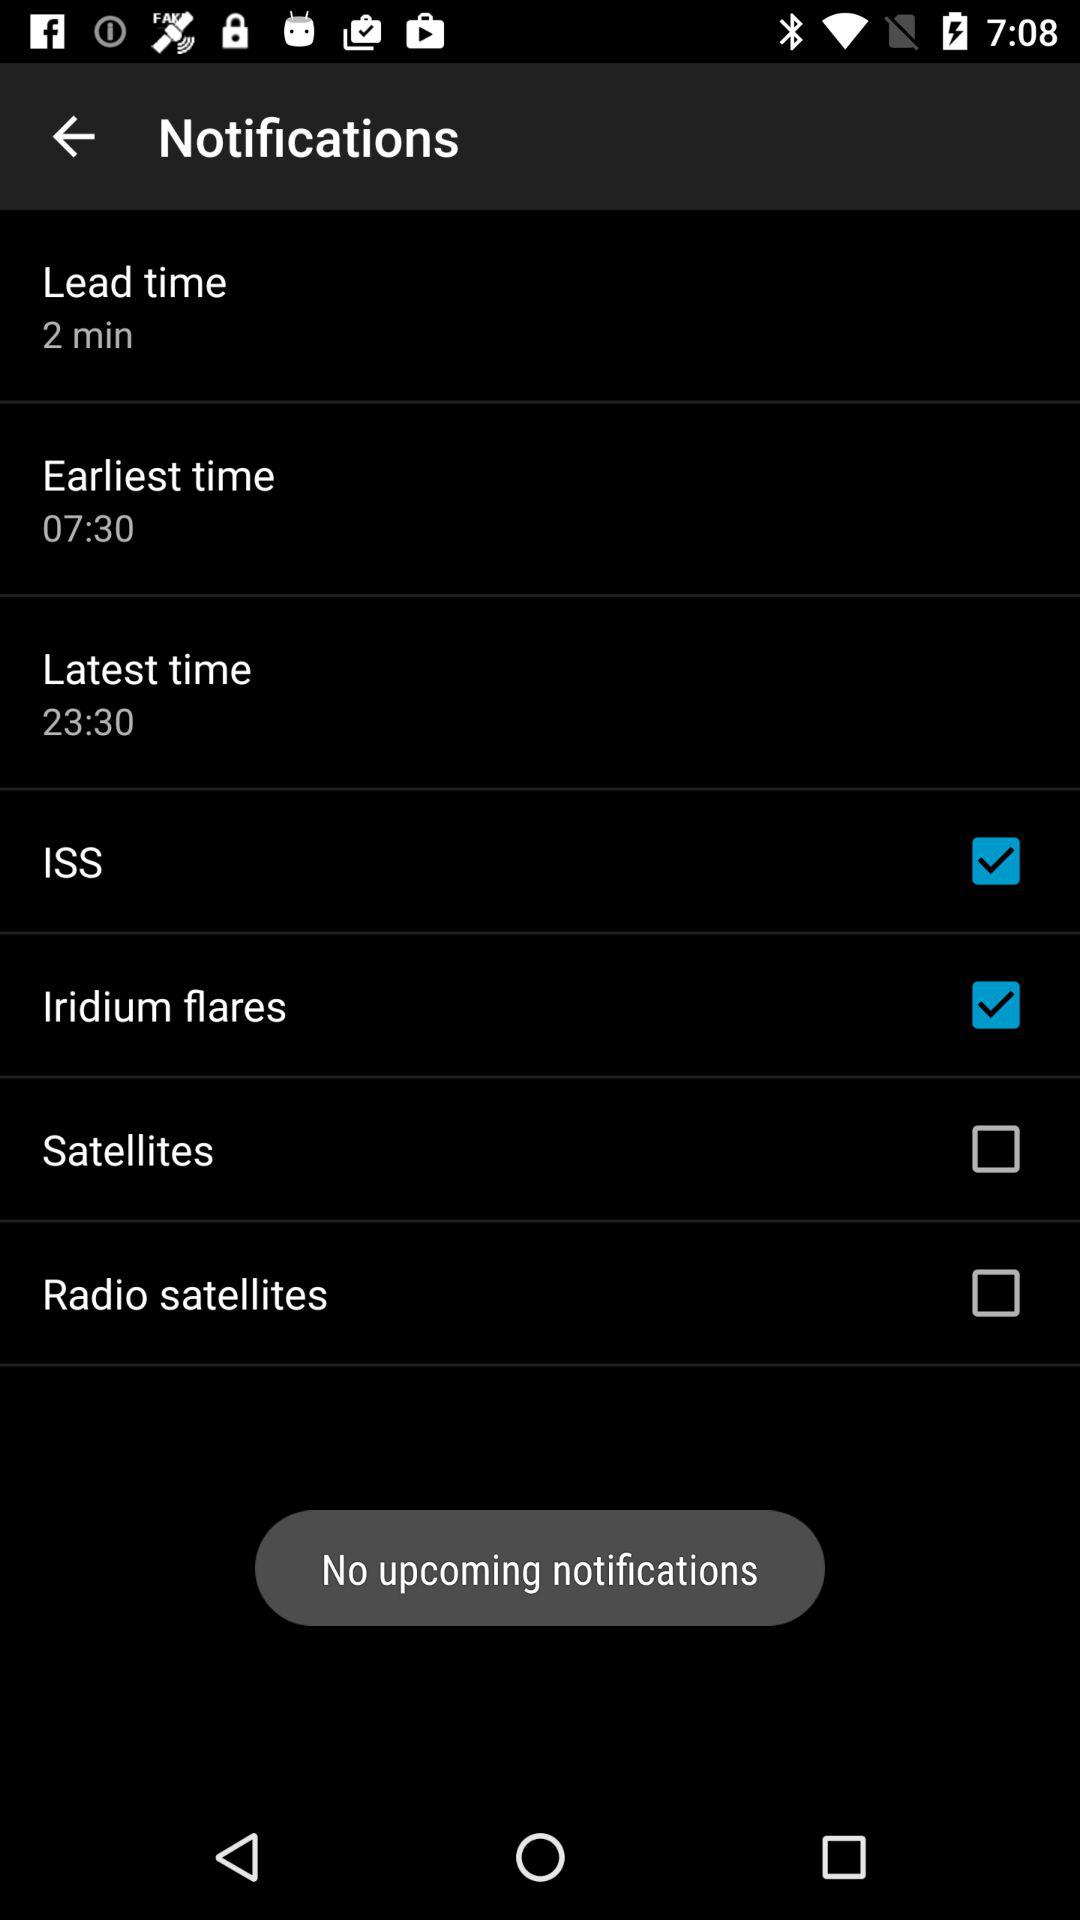What is the earliest time? The earliest time is 07:30. 